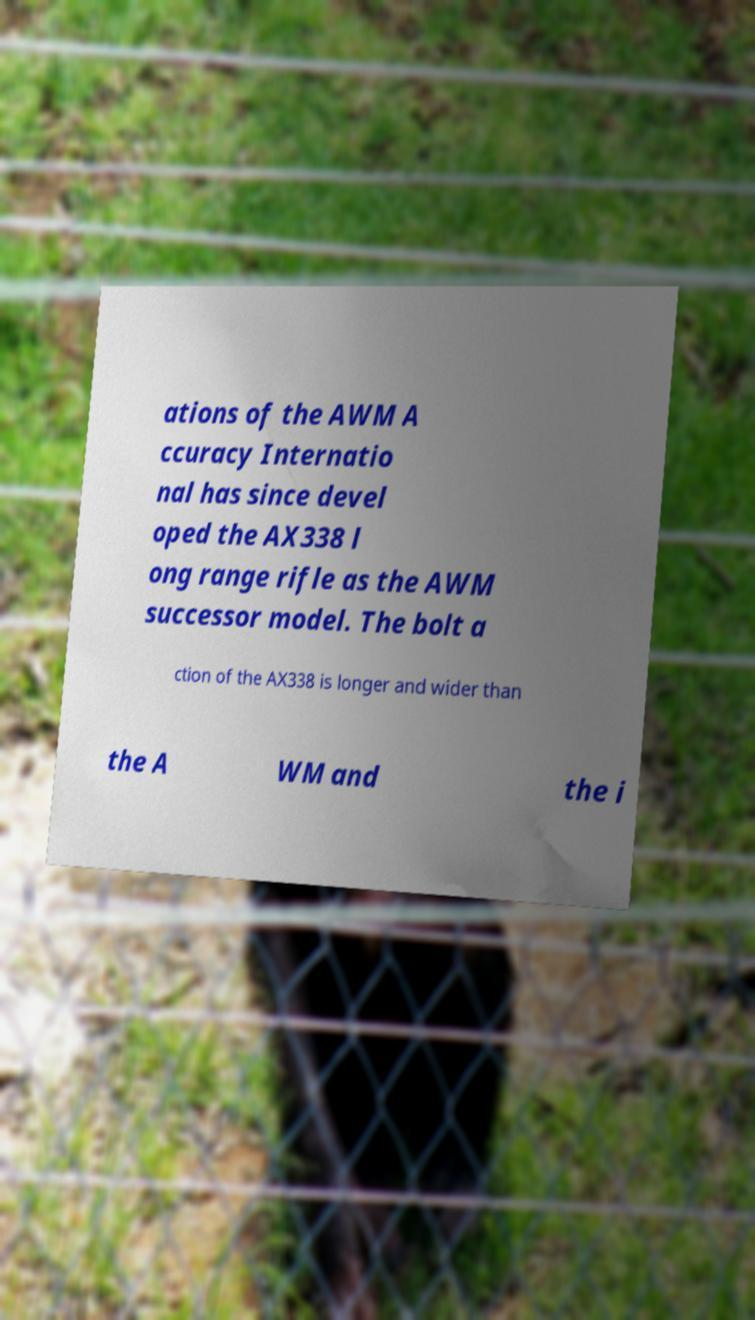Can you accurately transcribe the text from the provided image for me? ations of the AWM A ccuracy Internatio nal has since devel oped the AX338 l ong range rifle as the AWM successor model. The bolt a ction of the AX338 is longer and wider than the A WM and the i 